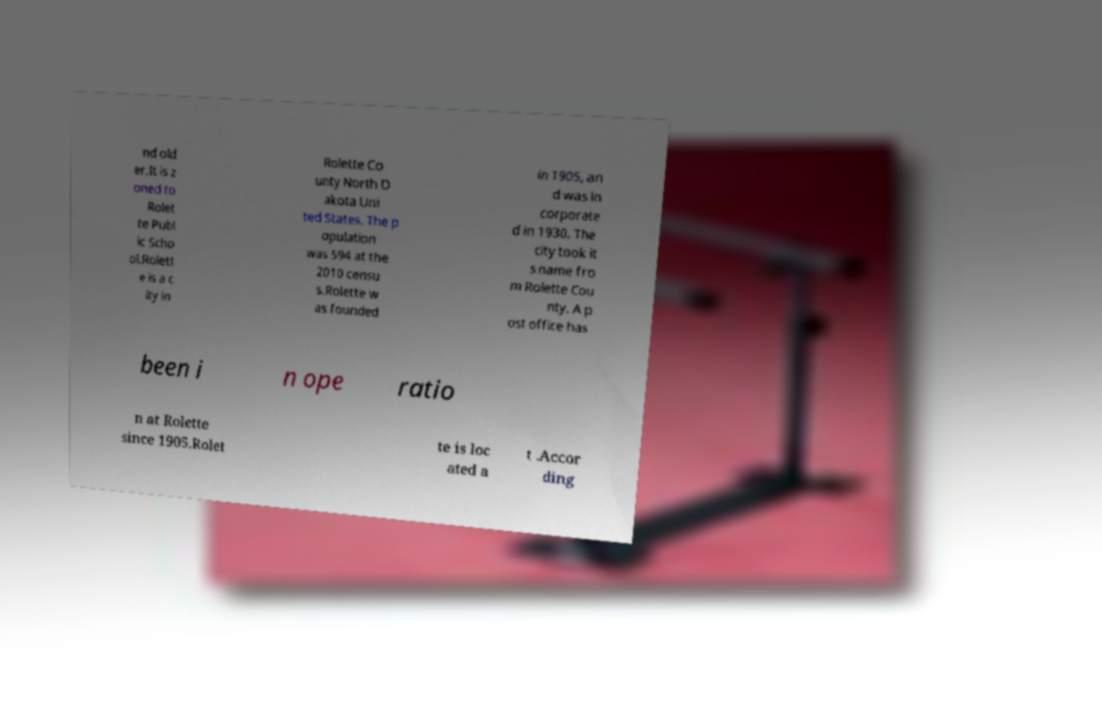I need the written content from this picture converted into text. Can you do that? nd old er.It is z oned to Rolet te Publ ic Scho ol.Rolett e is a c ity in Rolette Co unty North D akota Uni ted States. The p opulation was 594 at the 2010 censu s.Rolette w as founded in 1905, an d was in corporate d in 1930. The city took it s name fro m Rolette Cou nty. A p ost office has been i n ope ratio n at Rolette since 1905.Rolet te is loc ated a t .Accor ding 